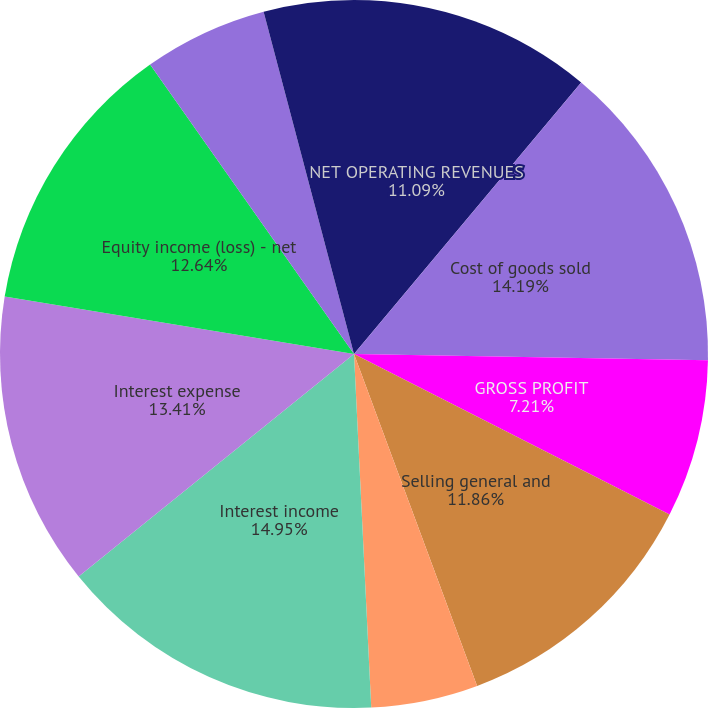<chart> <loc_0><loc_0><loc_500><loc_500><pie_chart><fcel>NET OPERATING REVENUES<fcel>Cost of goods sold<fcel>GROSS PROFIT<fcel>Selling general and<fcel>OPERATING INCOME<fcel>Interest income<fcel>Interest expense<fcel>Equity income (loss) - net<fcel>INCOME BEFORE INCOME TAXES<fcel>Income taxes<nl><fcel>11.09%<fcel>14.19%<fcel>7.21%<fcel>11.86%<fcel>4.88%<fcel>14.96%<fcel>13.41%<fcel>12.64%<fcel>5.66%<fcel>4.11%<nl></chart> 